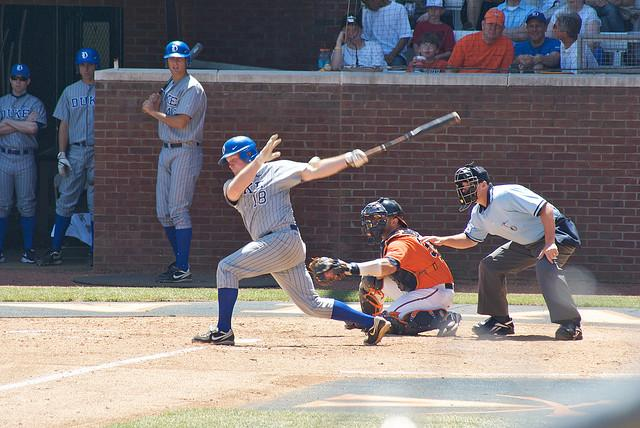What baseball player has the same first name as the name on the player all the way to the left's jersey? duke snider 